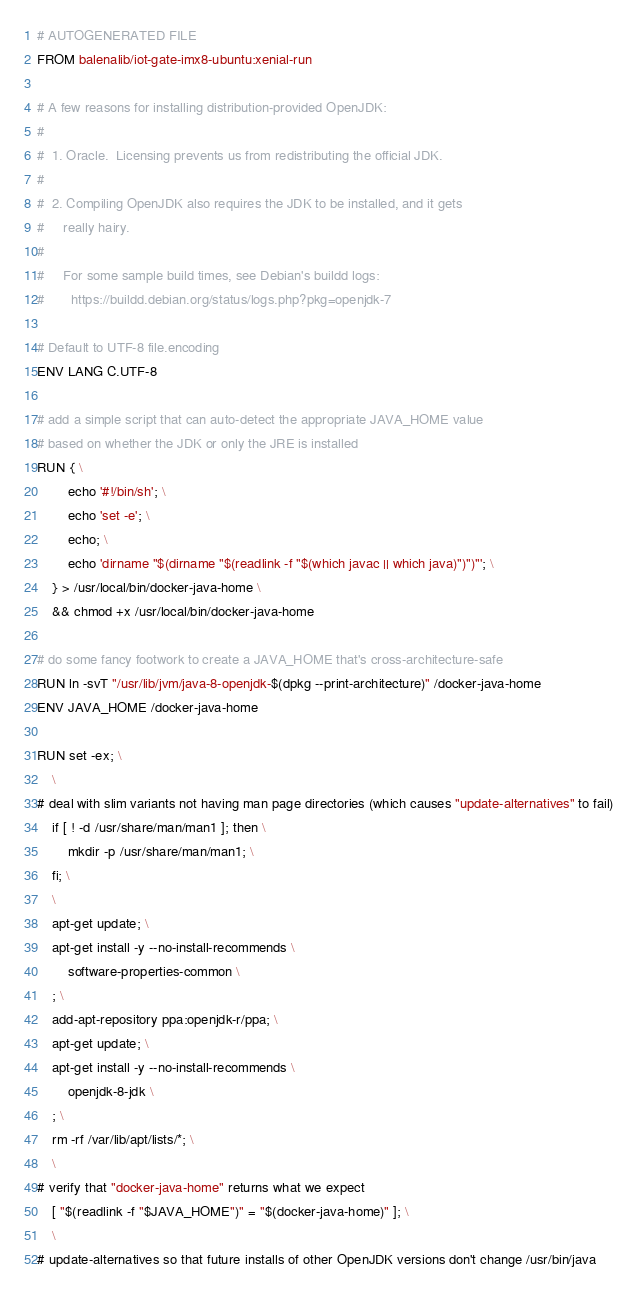<code> <loc_0><loc_0><loc_500><loc_500><_Dockerfile_># AUTOGENERATED FILE
FROM balenalib/iot-gate-imx8-ubuntu:xenial-run

# A few reasons for installing distribution-provided OpenJDK:
#
#  1. Oracle.  Licensing prevents us from redistributing the official JDK.
#
#  2. Compiling OpenJDK also requires the JDK to be installed, and it gets
#     really hairy.
#
#     For some sample build times, see Debian's buildd logs:
#       https://buildd.debian.org/status/logs.php?pkg=openjdk-7

# Default to UTF-8 file.encoding
ENV LANG C.UTF-8

# add a simple script that can auto-detect the appropriate JAVA_HOME value
# based on whether the JDK or only the JRE is installed
RUN { \
		echo '#!/bin/sh'; \
		echo 'set -e'; \
		echo; \
		echo 'dirname "$(dirname "$(readlink -f "$(which javac || which java)")")"'; \
	} > /usr/local/bin/docker-java-home \
	&& chmod +x /usr/local/bin/docker-java-home

# do some fancy footwork to create a JAVA_HOME that's cross-architecture-safe
RUN ln -svT "/usr/lib/jvm/java-8-openjdk-$(dpkg --print-architecture)" /docker-java-home
ENV JAVA_HOME /docker-java-home

RUN set -ex; \
	\
# deal with slim variants not having man page directories (which causes "update-alternatives" to fail)
	if [ ! -d /usr/share/man/man1 ]; then \
		mkdir -p /usr/share/man/man1; \
	fi; \
	\
	apt-get update; \
	apt-get install -y --no-install-recommends \
		software-properties-common \
	; \
	add-apt-repository ppa:openjdk-r/ppa; \
	apt-get update; \
	apt-get install -y --no-install-recommends \
		openjdk-8-jdk \
	; \
	rm -rf /var/lib/apt/lists/*; \
	\
# verify that "docker-java-home" returns what we expect
	[ "$(readlink -f "$JAVA_HOME")" = "$(docker-java-home)" ]; \
	\
# update-alternatives so that future installs of other OpenJDK versions don't change /usr/bin/java</code> 